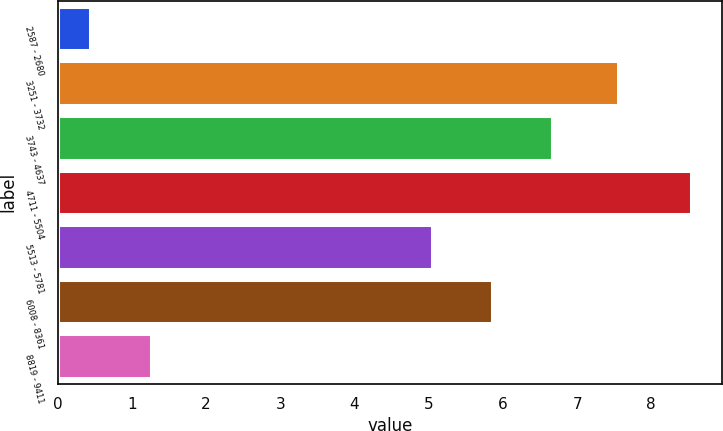<chart> <loc_0><loc_0><loc_500><loc_500><bar_chart><fcel>2587 - 2680<fcel>3251 - 3732<fcel>3743 - 4637<fcel>4711 - 5504<fcel>5513 - 5781<fcel>6008 - 8361<fcel>8819 - 9411<nl><fcel>0.44<fcel>7.55<fcel>6.66<fcel>8.53<fcel>5.04<fcel>5.85<fcel>1.25<nl></chart> 